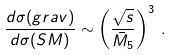<formula> <loc_0><loc_0><loc_500><loc_500>\frac { d \sigma ( g r a v ) } { d \sigma ( S M ) } \sim \left ( \frac { \sqrt { s } } { \bar { M } _ { 5 } } \right ) ^ { 3 } \, .</formula> 